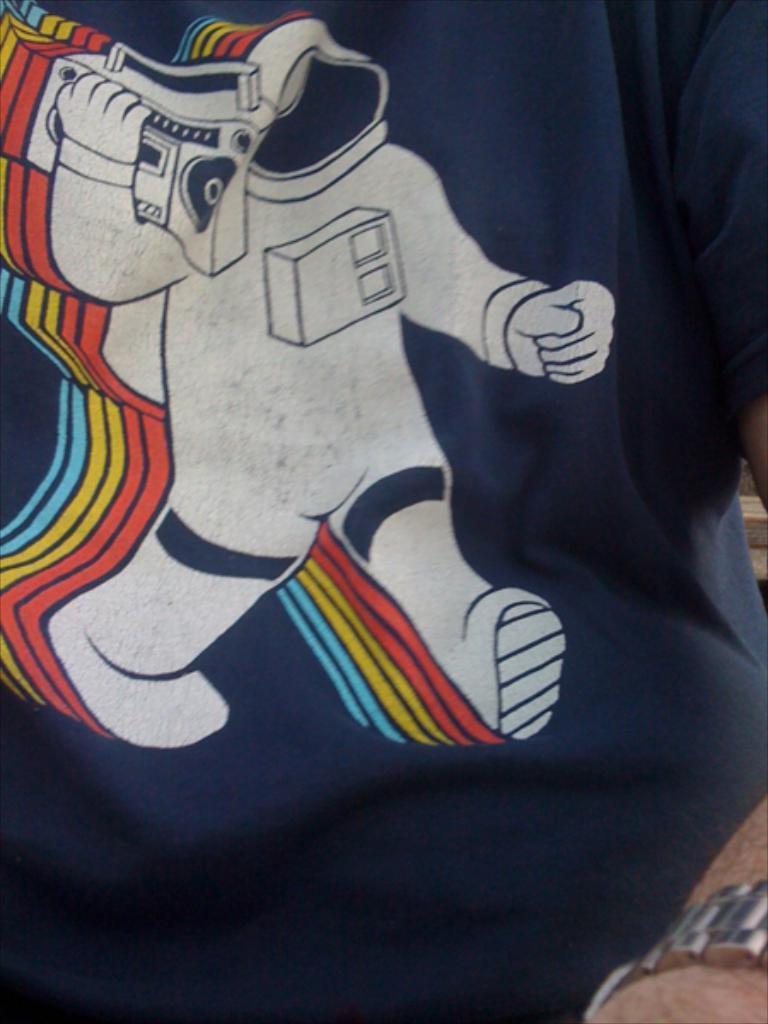Can you describe this image briefly? In this image I can see a person's hand and I can see this person is wearing blue colour dress. I can also see something over here. 